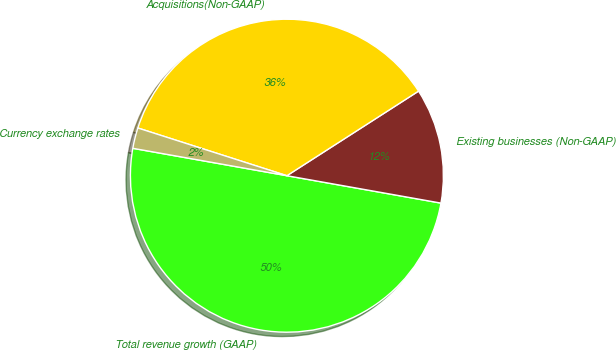Convert chart. <chart><loc_0><loc_0><loc_500><loc_500><pie_chart><fcel>Total revenue growth (GAAP)<fcel>Existing businesses (Non-GAAP)<fcel>Acquisitions(Non-GAAP)<fcel>Currency exchange rates<nl><fcel>50.0%<fcel>11.89%<fcel>35.98%<fcel>2.13%<nl></chart> 